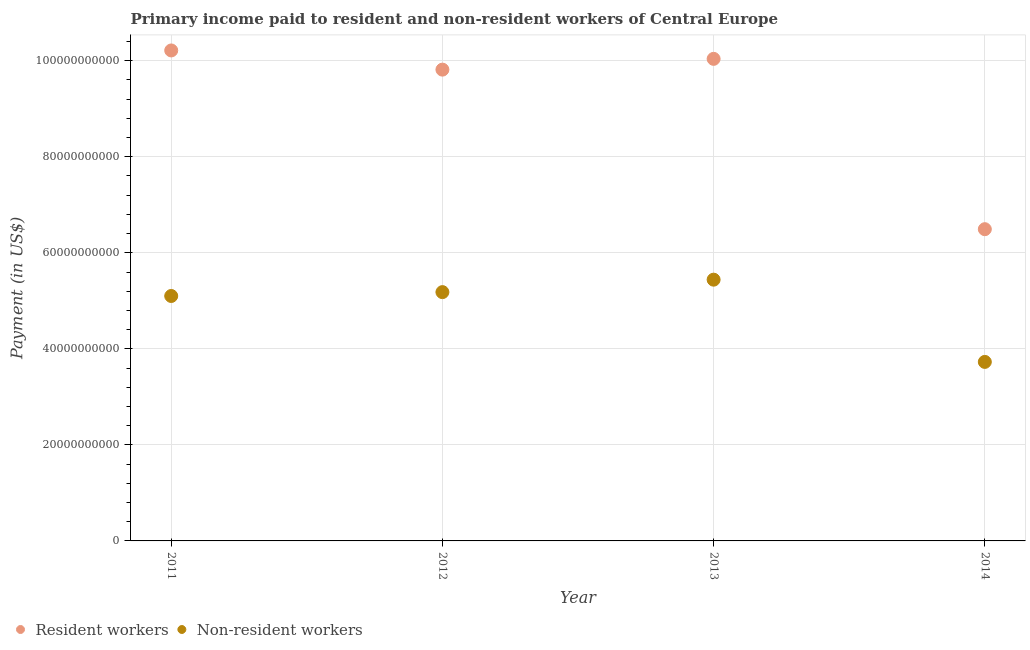Is the number of dotlines equal to the number of legend labels?
Make the answer very short. Yes. What is the payment made to resident workers in 2014?
Offer a very short reply. 6.49e+1. Across all years, what is the maximum payment made to resident workers?
Ensure brevity in your answer.  1.02e+11. Across all years, what is the minimum payment made to non-resident workers?
Provide a succinct answer. 3.73e+1. In which year was the payment made to resident workers minimum?
Provide a short and direct response. 2014. What is the total payment made to non-resident workers in the graph?
Offer a terse response. 1.95e+11. What is the difference between the payment made to non-resident workers in 2013 and that in 2014?
Give a very brief answer. 1.71e+1. What is the difference between the payment made to resident workers in 2011 and the payment made to non-resident workers in 2012?
Ensure brevity in your answer.  5.03e+1. What is the average payment made to non-resident workers per year?
Make the answer very short. 4.86e+1. In the year 2014, what is the difference between the payment made to resident workers and payment made to non-resident workers?
Ensure brevity in your answer.  2.76e+1. In how many years, is the payment made to resident workers greater than 36000000000 US$?
Provide a short and direct response. 4. What is the ratio of the payment made to non-resident workers in 2012 to that in 2014?
Ensure brevity in your answer.  1.39. Is the difference between the payment made to resident workers in 2012 and 2013 greater than the difference between the payment made to non-resident workers in 2012 and 2013?
Ensure brevity in your answer.  Yes. What is the difference between the highest and the second highest payment made to resident workers?
Offer a terse response. 1.75e+09. What is the difference between the highest and the lowest payment made to resident workers?
Your response must be concise. 3.72e+1. In how many years, is the payment made to resident workers greater than the average payment made to resident workers taken over all years?
Your response must be concise. 3. Is the sum of the payment made to resident workers in 2013 and 2014 greater than the maximum payment made to non-resident workers across all years?
Make the answer very short. Yes. Does the payment made to non-resident workers monotonically increase over the years?
Your answer should be compact. No. Is the payment made to non-resident workers strictly greater than the payment made to resident workers over the years?
Offer a very short reply. No. Is the payment made to resident workers strictly less than the payment made to non-resident workers over the years?
Make the answer very short. No. How many dotlines are there?
Give a very brief answer. 2. How many years are there in the graph?
Offer a very short reply. 4. What is the difference between two consecutive major ticks on the Y-axis?
Your answer should be very brief. 2.00e+1. Are the values on the major ticks of Y-axis written in scientific E-notation?
Make the answer very short. No. Where does the legend appear in the graph?
Offer a very short reply. Bottom left. How many legend labels are there?
Keep it short and to the point. 2. How are the legend labels stacked?
Offer a very short reply. Horizontal. What is the title of the graph?
Provide a short and direct response. Primary income paid to resident and non-resident workers of Central Europe. What is the label or title of the X-axis?
Give a very brief answer. Year. What is the label or title of the Y-axis?
Your answer should be very brief. Payment (in US$). What is the Payment (in US$) of Resident workers in 2011?
Offer a terse response. 1.02e+11. What is the Payment (in US$) of Non-resident workers in 2011?
Ensure brevity in your answer.  5.10e+1. What is the Payment (in US$) of Resident workers in 2012?
Ensure brevity in your answer.  9.81e+1. What is the Payment (in US$) in Non-resident workers in 2012?
Keep it short and to the point. 5.18e+1. What is the Payment (in US$) in Resident workers in 2013?
Make the answer very short. 1.00e+11. What is the Payment (in US$) in Non-resident workers in 2013?
Offer a terse response. 5.44e+1. What is the Payment (in US$) in Resident workers in 2014?
Ensure brevity in your answer.  6.49e+1. What is the Payment (in US$) in Non-resident workers in 2014?
Give a very brief answer. 3.73e+1. Across all years, what is the maximum Payment (in US$) in Resident workers?
Provide a succinct answer. 1.02e+11. Across all years, what is the maximum Payment (in US$) in Non-resident workers?
Offer a terse response. 5.44e+1. Across all years, what is the minimum Payment (in US$) of Resident workers?
Your response must be concise. 6.49e+1. Across all years, what is the minimum Payment (in US$) of Non-resident workers?
Provide a short and direct response. 3.73e+1. What is the total Payment (in US$) of Resident workers in the graph?
Give a very brief answer. 3.66e+11. What is the total Payment (in US$) of Non-resident workers in the graph?
Your response must be concise. 1.95e+11. What is the difference between the Payment (in US$) of Resident workers in 2011 and that in 2012?
Provide a short and direct response. 4.00e+09. What is the difference between the Payment (in US$) in Non-resident workers in 2011 and that in 2012?
Your answer should be very brief. -8.04e+08. What is the difference between the Payment (in US$) of Resident workers in 2011 and that in 2013?
Keep it short and to the point. 1.75e+09. What is the difference between the Payment (in US$) of Non-resident workers in 2011 and that in 2013?
Keep it short and to the point. -3.40e+09. What is the difference between the Payment (in US$) of Resident workers in 2011 and that in 2014?
Provide a short and direct response. 3.72e+1. What is the difference between the Payment (in US$) of Non-resident workers in 2011 and that in 2014?
Offer a very short reply. 1.37e+1. What is the difference between the Payment (in US$) of Resident workers in 2012 and that in 2013?
Provide a succinct answer. -2.24e+09. What is the difference between the Payment (in US$) of Non-resident workers in 2012 and that in 2013?
Give a very brief answer. -2.59e+09. What is the difference between the Payment (in US$) of Resident workers in 2012 and that in 2014?
Offer a terse response. 3.32e+1. What is the difference between the Payment (in US$) in Non-resident workers in 2012 and that in 2014?
Your answer should be compact. 1.45e+1. What is the difference between the Payment (in US$) in Resident workers in 2013 and that in 2014?
Give a very brief answer. 3.55e+1. What is the difference between the Payment (in US$) in Non-resident workers in 2013 and that in 2014?
Offer a terse response. 1.71e+1. What is the difference between the Payment (in US$) in Resident workers in 2011 and the Payment (in US$) in Non-resident workers in 2012?
Your answer should be very brief. 5.03e+1. What is the difference between the Payment (in US$) in Resident workers in 2011 and the Payment (in US$) in Non-resident workers in 2013?
Offer a terse response. 4.77e+1. What is the difference between the Payment (in US$) of Resident workers in 2011 and the Payment (in US$) of Non-resident workers in 2014?
Provide a succinct answer. 6.49e+1. What is the difference between the Payment (in US$) in Resident workers in 2012 and the Payment (in US$) in Non-resident workers in 2013?
Give a very brief answer. 4.37e+1. What is the difference between the Payment (in US$) of Resident workers in 2012 and the Payment (in US$) of Non-resident workers in 2014?
Offer a terse response. 6.09e+1. What is the difference between the Payment (in US$) of Resident workers in 2013 and the Payment (in US$) of Non-resident workers in 2014?
Give a very brief answer. 6.31e+1. What is the average Payment (in US$) in Resident workers per year?
Your answer should be compact. 9.14e+1. What is the average Payment (in US$) of Non-resident workers per year?
Your answer should be compact. 4.86e+1. In the year 2011, what is the difference between the Payment (in US$) of Resident workers and Payment (in US$) of Non-resident workers?
Keep it short and to the point. 5.11e+1. In the year 2012, what is the difference between the Payment (in US$) in Resident workers and Payment (in US$) in Non-resident workers?
Ensure brevity in your answer.  4.63e+1. In the year 2013, what is the difference between the Payment (in US$) of Resident workers and Payment (in US$) of Non-resident workers?
Provide a short and direct response. 4.60e+1. In the year 2014, what is the difference between the Payment (in US$) of Resident workers and Payment (in US$) of Non-resident workers?
Offer a terse response. 2.76e+1. What is the ratio of the Payment (in US$) of Resident workers in 2011 to that in 2012?
Your answer should be compact. 1.04. What is the ratio of the Payment (in US$) of Non-resident workers in 2011 to that in 2012?
Make the answer very short. 0.98. What is the ratio of the Payment (in US$) in Resident workers in 2011 to that in 2013?
Offer a very short reply. 1.02. What is the ratio of the Payment (in US$) of Resident workers in 2011 to that in 2014?
Ensure brevity in your answer.  1.57. What is the ratio of the Payment (in US$) of Non-resident workers in 2011 to that in 2014?
Ensure brevity in your answer.  1.37. What is the ratio of the Payment (in US$) of Resident workers in 2012 to that in 2013?
Offer a very short reply. 0.98. What is the ratio of the Payment (in US$) of Non-resident workers in 2012 to that in 2013?
Make the answer very short. 0.95. What is the ratio of the Payment (in US$) of Resident workers in 2012 to that in 2014?
Your answer should be compact. 1.51. What is the ratio of the Payment (in US$) in Non-resident workers in 2012 to that in 2014?
Offer a very short reply. 1.39. What is the ratio of the Payment (in US$) of Resident workers in 2013 to that in 2014?
Provide a short and direct response. 1.55. What is the ratio of the Payment (in US$) of Non-resident workers in 2013 to that in 2014?
Offer a terse response. 1.46. What is the difference between the highest and the second highest Payment (in US$) in Resident workers?
Provide a short and direct response. 1.75e+09. What is the difference between the highest and the second highest Payment (in US$) of Non-resident workers?
Your answer should be very brief. 2.59e+09. What is the difference between the highest and the lowest Payment (in US$) in Resident workers?
Your answer should be very brief. 3.72e+1. What is the difference between the highest and the lowest Payment (in US$) in Non-resident workers?
Offer a terse response. 1.71e+1. 